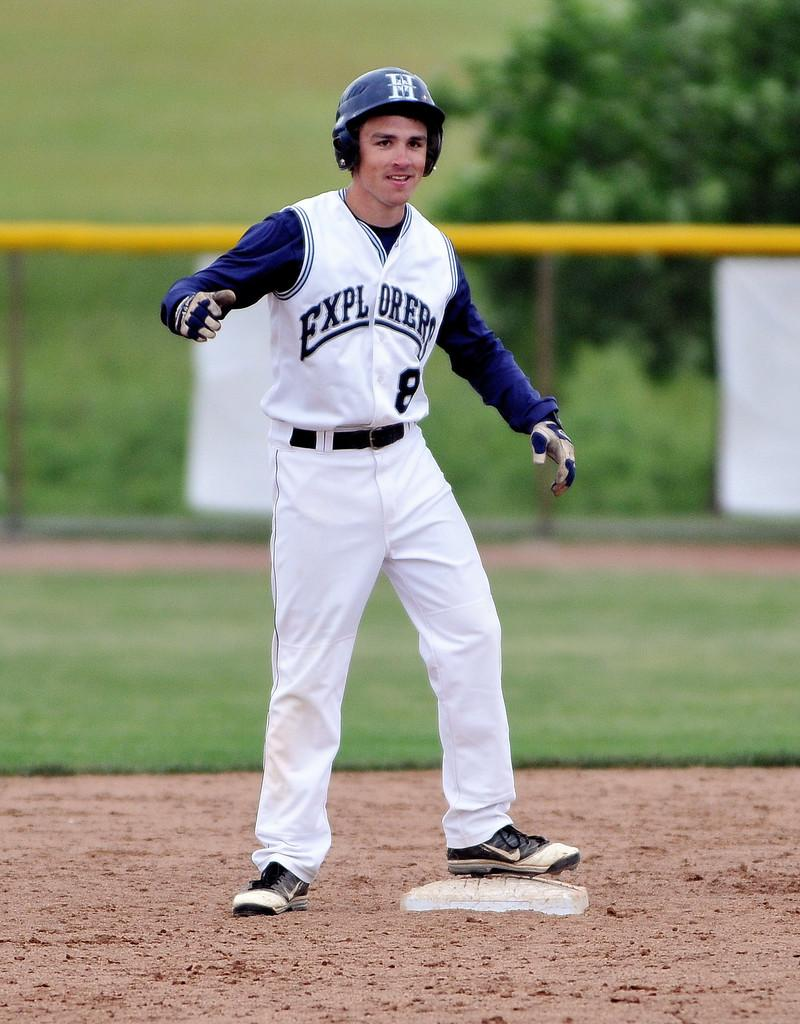<image>
Provide a brief description of the given image. A young man in a Explorers baseball uniform in blue and white standing on a base on a baseball field. 